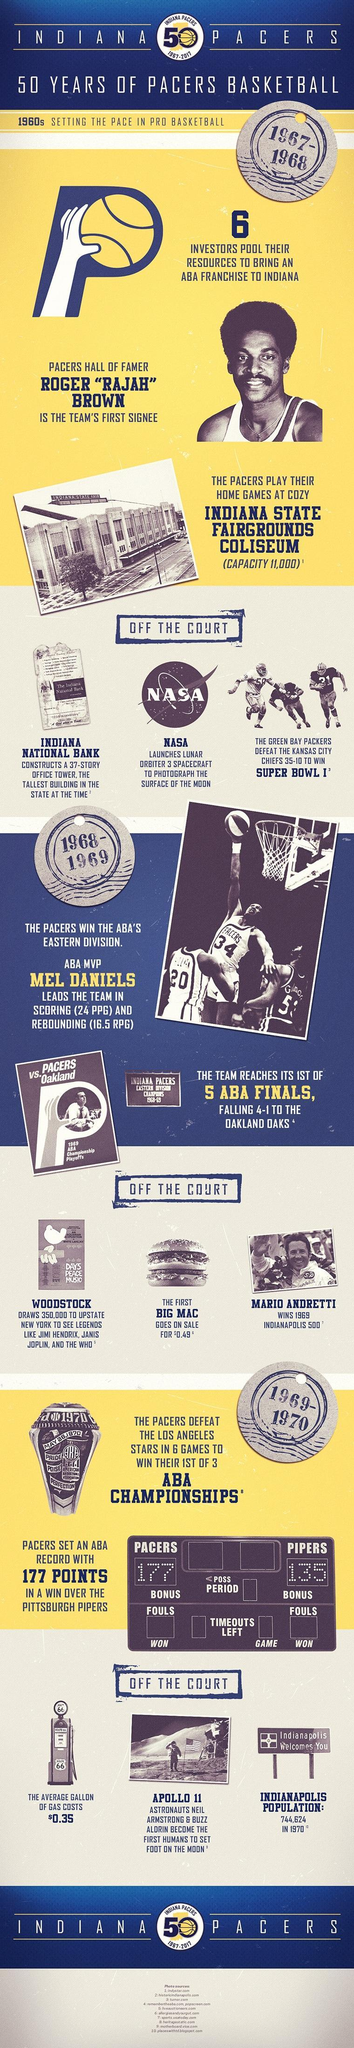When did then team reach its 1st of 5 ABA finals
Answer the question with a short phrase. 1968-69 What was the cost of the first Big Mac in dollars 0.49 When did NASA launch lunar orbiter 3 spacecraft to photograph the surface of the moon 1967-68 What was the vehicle name used by Neil Armstrong to become the first human to set foot on the moon Apollo 11 When did Pacers win their 1st of 3 ABA Championships 1969-70 Who constructed the tallest building in the state in 1967-68 Indiana National Bank What was the cost of a gallon gas in 1969-1970 $0.35 